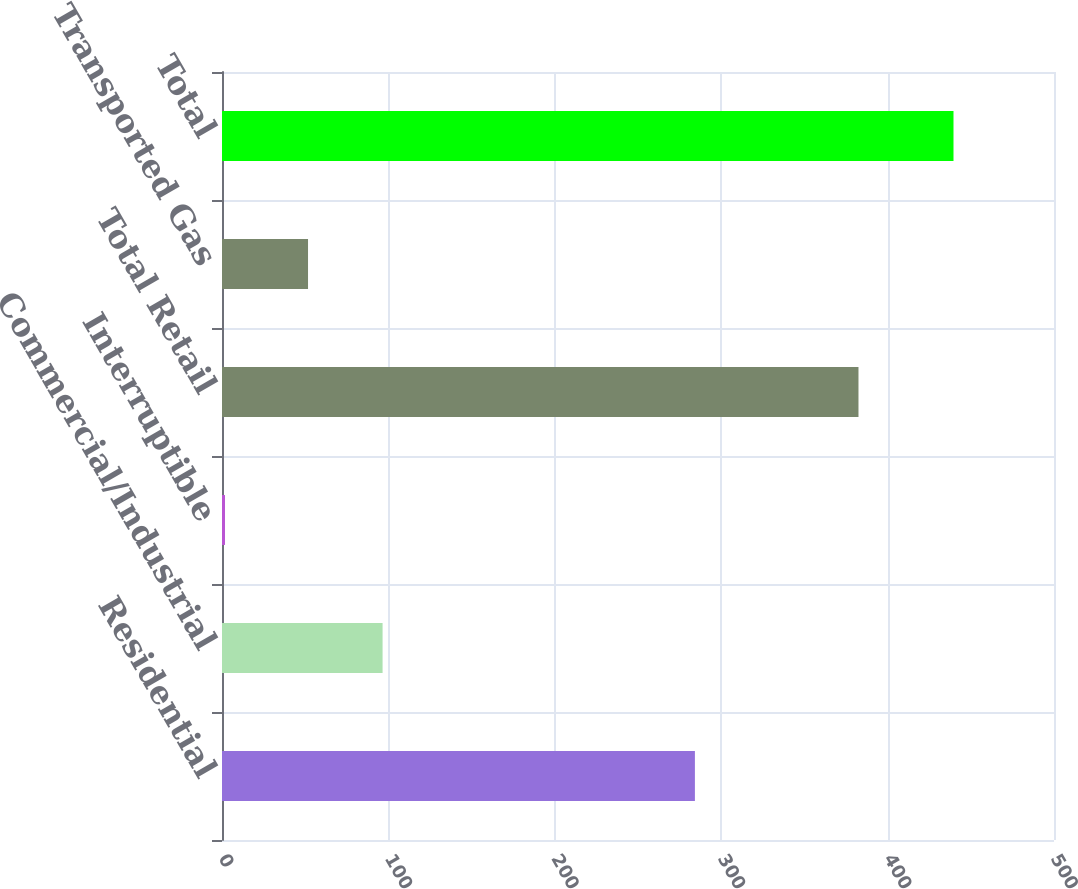Convert chart to OTSL. <chart><loc_0><loc_0><loc_500><loc_500><bar_chart><fcel>Residential<fcel>Commercial/Industrial<fcel>Interruptible<fcel>Total Retail<fcel>Transported Gas<fcel>Total<nl><fcel>284.2<fcel>96.5<fcel>1.8<fcel>382.5<fcel>51.7<fcel>439.6<nl></chart> 